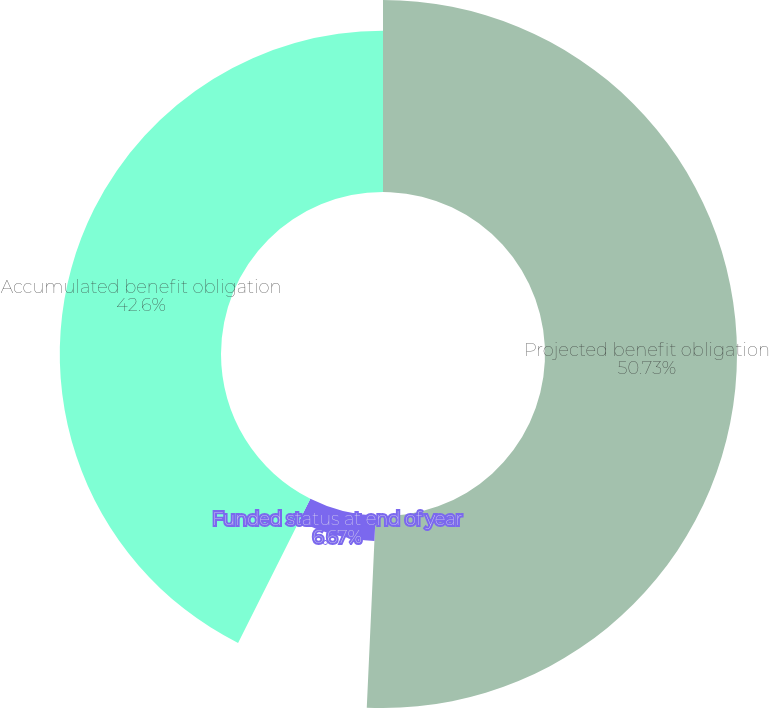Convert chart. <chart><loc_0><loc_0><loc_500><loc_500><pie_chart><fcel>Projected benefit obligation<fcel>Funded status at end of year<fcel>Accumulated benefit obligation<nl><fcel>50.73%<fcel>6.67%<fcel>42.6%<nl></chart> 